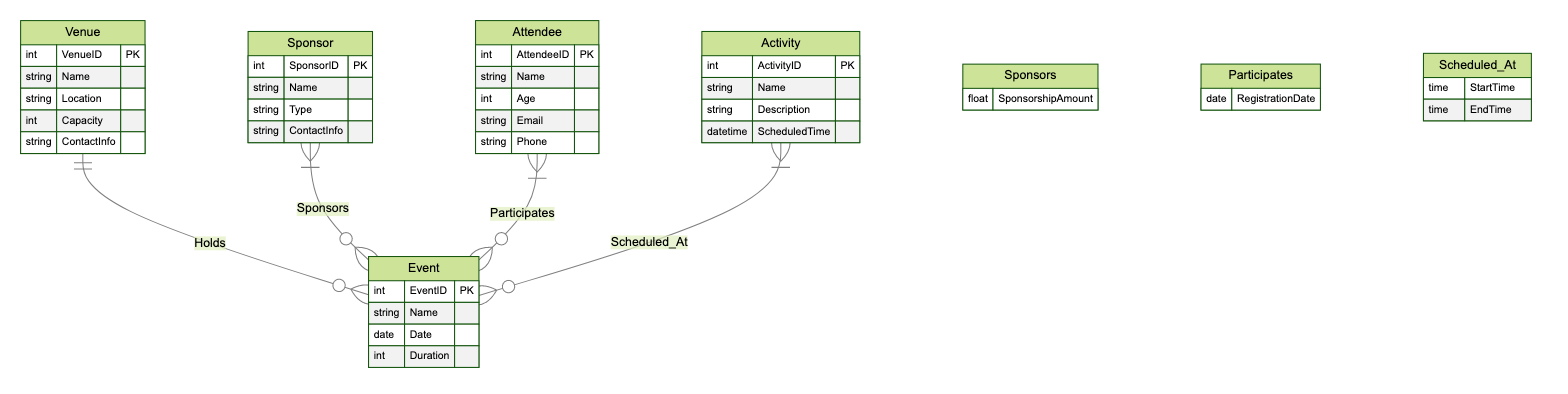What entities are included in the diagram? The diagram includes five entities: Venue, Sponsor, Attendee, Activity, and Event. These names can be directly observed in the diagram's entity section.
Answer: Venue, Sponsor, Attendee, Activity, Event How many attributes does the Venue entity have? The Venue entity has five attributes: VenueID, Name, Location, Capacity, and ContactInfo. This can be counted directly from the list of attributes under the Venue entity in the diagram.
Answer: 5 What relationship connects Attendee and Event? The relationship that connects Attendee and Event is called "Participates." This can be identified in the relationships section of the diagram, showing the connection between the two entities.
Answer: Participates How many relationships are depicted in the diagram? The diagram depicts four relationships: Holds, Sponsors, Participates, and Scheduled_At. Each relationship can be seen listed in the relationships section of the diagram.
Answer: 4 What attribute is associated with the relationship between Sponsor and Event? The attribute associated with the relationship between Sponsor and Event is "SponsorshipAmount." This is specified in the relationship description between the two entities in the diagram.
Answer: SponsorshipAmount What type of entity is "Activity"? "Activity" is categorized as an entity within the diagram. It specifically represents activities that can be scheduled at an event and is included in the list of entities provided.
Answer: Entity Which entity has a Capacity attribute? The entity that has a Capacity attribute is "Venue." This can be confirmed by checking the attributes listed for the Venue entity in the diagram.
Answer: Venue How many entities have a ContactInfo attribute? Two entities have a ContactInfo attribute: Venue and Sponsor. This can be determined by looking at the attributes of each entity and counting those that include ContactInfo.
Answer: 2 